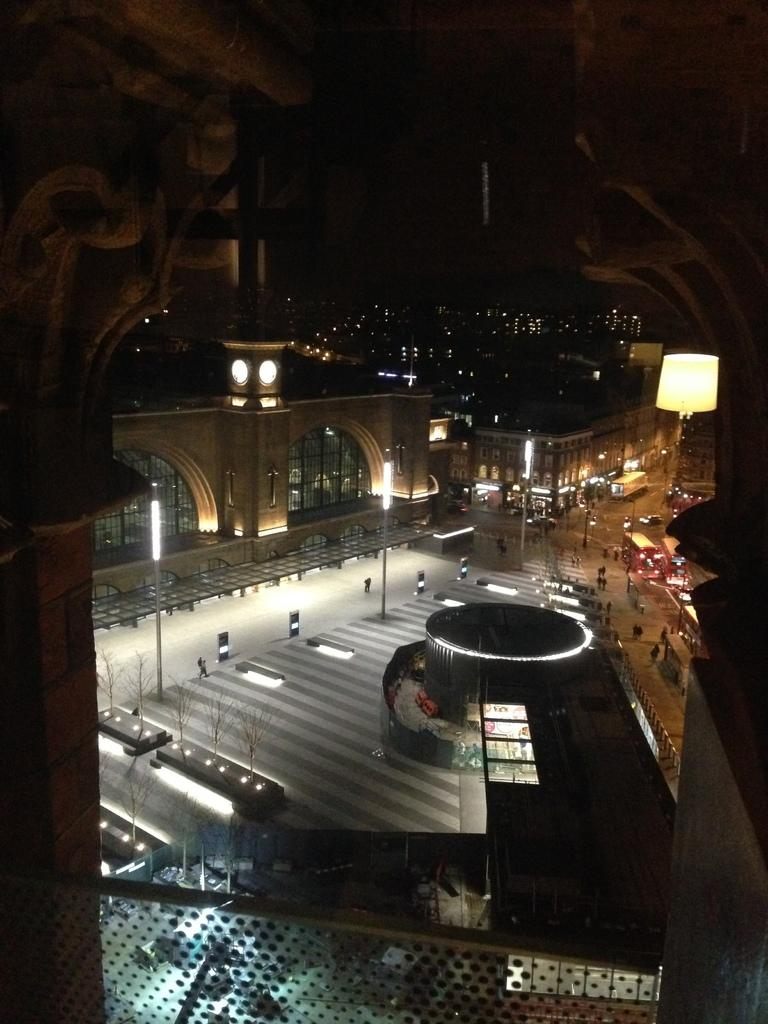What type of structures can be seen in the image? There are buildings in the image. What can be observed illuminating the scene in the image? There are lights visible in the image. What mode of transportation is present in the image? Vehicles are moving on the road in the image. What type of activity can be seen involving people in the image? There are people walking in the image. What is the price of the representative ghost in the image? There is no representative ghost present in the image, and therefore no price can be determined. 